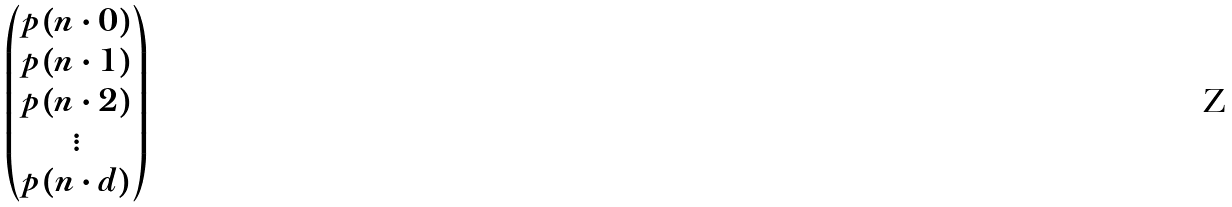Convert formula to latex. <formula><loc_0><loc_0><loc_500><loc_500>\begin{pmatrix} p ( n \cdot 0 ) \\ p ( n \cdot 1 ) \\ p ( n \cdot 2 ) \\ \vdots \\ p ( n \cdot d ) \end{pmatrix}</formula> 